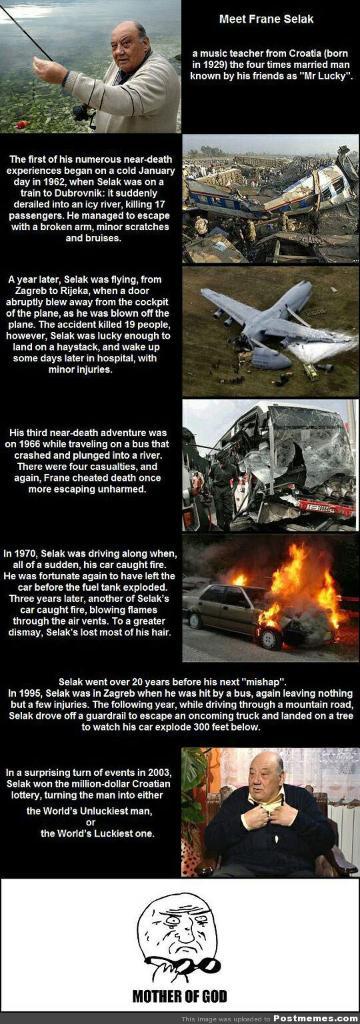What does the last picture say?
Provide a succinct answer. Mother of god. Who is this photo about?
Provide a succinct answer. Frane selak. 